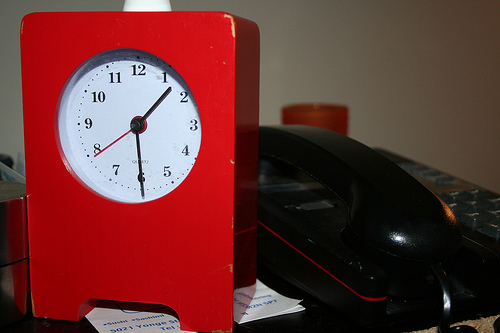<image>
Is the clock on the paper? Yes. Looking at the image, I can see the clock is positioned on top of the paper, with the paper providing support. 